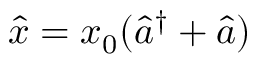<formula> <loc_0><loc_0><loc_500><loc_500>\hat { x } = x _ { 0 } ( \hat { a } ^ { \dag } + \hat { a } )</formula> 